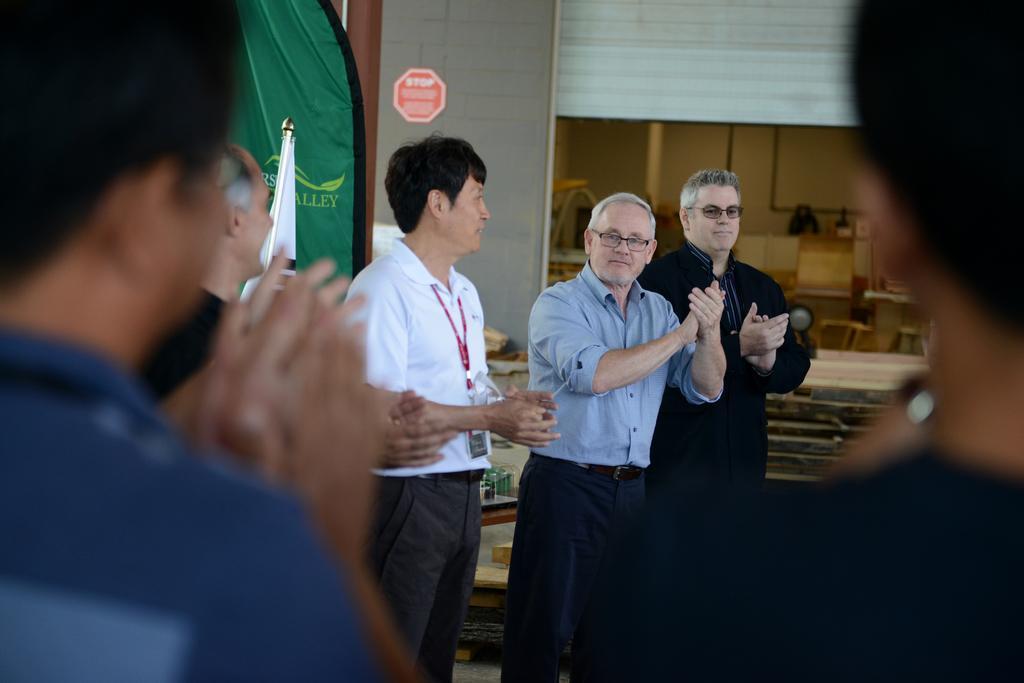How would you summarize this image in a sentence or two? In this image I can see group of people standing, the person in front wearing white shirt, gray pant and the other person wearing blue shirt. Background I can see a flag in white color and a cloth in green color and the wall is in gray color. 